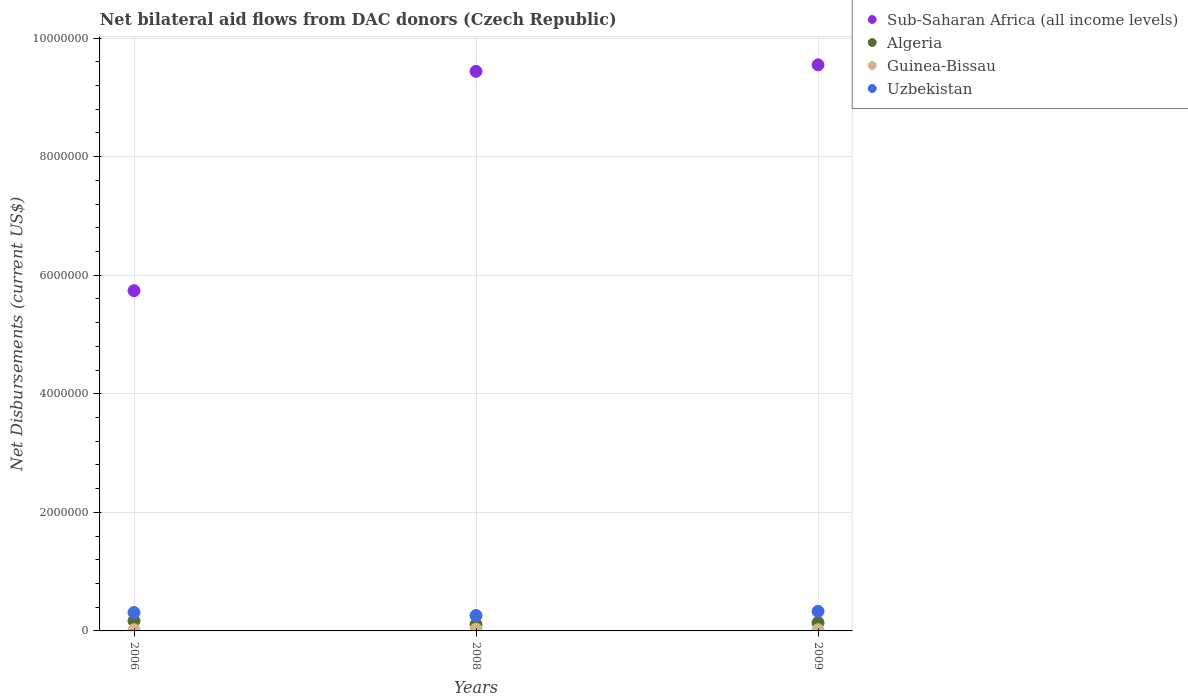How many different coloured dotlines are there?
Make the answer very short. 4. Is the number of dotlines equal to the number of legend labels?
Provide a short and direct response. Yes. What is the net bilateral aid flows in Algeria in 2008?
Your answer should be very brief. 1.10e+05. In which year was the net bilateral aid flows in Guinea-Bissau maximum?
Your answer should be compact. 2008. What is the total net bilateral aid flows in Guinea-Bissau in the graph?
Provide a short and direct response. 7.00e+04. What is the difference between the net bilateral aid flows in Uzbekistan in 2006 and that in 2008?
Offer a terse response. 5.00e+04. What is the difference between the net bilateral aid flows in Uzbekistan in 2006 and the net bilateral aid flows in Sub-Saharan Africa (all income levels) in 2009?
Your answer should be very brief. -9.24e+06. What is the average net bilateral aid flows in Guinea-Bissau per year?
Offer a very short reply. 2.33e+04. In how many years, is the net bilateral aid flows in Algeria greater than 9200000 US$?
Provide a short and direct response. 0. What is the ratio of the net bilateral aid flows in Uzbekistan in 2006 to that in 2008?
Ensure brevity in your answer.  1.19. What is the difference between the highest and the second highest net bilateral aid flows in Algeria?
Offer a terse response. 3.00e+04. What is the difference between the highest and the lowest net bilateral aid flows in Algeria?
Offer a terse response. 6.00e+04. Is the sum of the net bilateral aid flows in Guinea-Bissau in 2006 and 2008 greater than the maximum net bilateral aid flows in Algeria across all years?
Make the answer very short. No. Is it the case that in every year, the sum of the net bilateral aid flows in Sub-Saharan Africa (all income levels) and net bilateral aid flows in Guinea-Bissau  is greater than the sum of net bilateral aid flows in Algeria and net bilateral aid flows in Uzbekistan?
Ensure brevity in your answer.  Yes. Is the net bilateral aid flows in Uzbekistan strictly less than the net bilateral aid flows in Algeria over the years?
Offer a terse response. No. How many dotlines are there?
Your response must be concise. 4. How many years are there in the graph?
Keep it short and to the point. 3. What is the difference between two consecutive major ticks on the Y-axis?
Give a very brief answer. 2.00e+06. Are the values on the major ticks of Y-axis written in scientific E-notation?
Keep it short and to the point. No. Does the graph contain any zero values?
Give a very brief answer. No. Where does the legend appear in the graph?
Provide a succinct answer. Top right. How many legend labels are there?
Give a very brief answer. 4. How are the legend labels stacked?
Ensure brevity in your answer.  Vertical. What is the title of the graph?
Provide a short and direct response. Net bilateral aid flows from DAC donors (Czech Republic). What is the label or title of the X-axis?
Offer a very short reply. Years. What is the label or title of the Y-axis?
Offer a very short reply. Net Disbursements (current US$). What is the Net Disbursements (current US$) of Sub-Saharan Africa (all income levels) in 2006?
Provide a short and direct response. 5.74e+06. What is the Net Disbursements (current US$) of Algeria in 2006?
Keep it short and to the point. 1.70e+05. What is the Net Disbursements (current US$) in Sub-Saharan Africa (all income levels) in 2008?
Keep it short and to the point. 9.44e+06. What is the Net Disbursements (current US$) in Algeria in 2008?
Give a very brief answer. 1.10e+05. What is the Net Disbursements (current US$) of Guinea-Bissau in 2008?
Your response must be concise. 3.00e+04. What is the Net Disbursements (current US$) in Uzbekistan in 2008?
Your answer should be compact. 2.60e+05. What is the Net Disbursements (current US$) in Sub-Saharan Africa (all income levels) in 2009?
Your answer should be very brief. 9.55e+06. What is the Net Disbursements (current US$) in Uzbekistan in 2009?
Give a very brief answer. 3.30e+05. Across all years, what is the maximum Net Disbursements (current US$) of Sub-Saharan Africa (all income levels)?
Keep it short and to the point. 9.55e+06. Across all years, what is the maximum Net Disbursements (current US$) in Algeria?
Your response must be concise. 1.70e+05. Across all years, what is the minimum Net Disbursements (current US$) in Sub-Saharan Africa (all income levels)?
Your response must be concise. 5.74e+06. Across all years, what is the minimum Net Disbursements (current US$) of Algeria?
Offer a very short reply. 1.10e+05. Across all years, what is the minimum Net Disbursements (current US$) in Guinea-Bissau?
Your answer should be very brief. 2.00e+04. Across all years, what is the minimum Net Disbursements (current US$) of Uzbekistan?
Make the answer very short. 2.60e+05. What is the total Net Disbursements (current US$) of Sub-Saharan Africa (all income levels) in the graph?
Keep it short and to the point. 2.47e+07. What is the total Net Disbursements (current US$) of Guinea-Bissau in the graph?
Offer a terse response. 7.00e+04. What is the total Net Disbursements (current US$) in Uzbekistan in the graph?
Keep it short and to the point. 9.00e+05. What is the difference between the Net Disbursements (current US$) in Sub-Saharan Africa (all income levels) in 2006 and that in 2008?
Provide a succinct answer. -3.70e+06. What is the difference between the Net Disbursements (current US$) in Algeria in 2006 and that in 2008?
Keep it short and to the point. 6.00e+04. What is the difference between the Net Disbursements (current US$) of Uzbekistan in 2006 and that in 2008?
Make the answer very short. 5.00e+04. What is the difference between the Net Disbursements (current US$) in Sub-Saharan Africa (all income levels) in 2006 and that in 2009?
Keep it short and to the point. -3.81e+06. What is the difference between the Net Disbursements (current US$) of Algeria in 2006 and that in 2009?
Provide a succinct answer. 3.00e+04. What is the difference between the Net Disbursements (current US$) of Sub-Saharan Africa (all income levels) in 2008 and that in 2009?
Your response must be concise. -1.10e+05. What is the difference between the Net Disbursements (current US$) in Sub-Saharan Africa (all income levels) in 2006 and the Net Disbursements (current US$) in Algeria in 2008?
Give a very brief answer. 5.63e+06. What is the difference between the Net Disbursements (current US$) of Sub-Saharan Africa (all income levels) in 2006 and the Net Disbursements (current US$) of Guinea-Bissau in 2008?
Provide a succinct answer. 5.71e+06. What is the difference between the Net Disbursements (current US$) in Sub-Saharan Africa (all income levels) in 2006 and the Net Disbursements (current US$) in Uzbekistan in 2008?
Make the answer very short. 5.48e+06. What is the difference between the Net Disbursements (current US$) of Algeria in 2006 and the Net Disbursements (current US$) of Guinea-Bissau in 2008?
Offer a terse response. 1.40e+05. What is the difference between the Net Disbursements (current US$) of Algeria in 2006 and the Net Disbursements (current US$) of Uzbekistan in 2008?
Give a very brief answer. -9.00e+04. What is the difference between the Net Disbursements (current US$) of Sub-Saharan Africa (all income levels) in 2006 and the Net Disbursements (current US$) of Algeria in 2009?
Keep it short and to the point. 5.60e+06. What is the difference between the Net Disbursements (current US$) of Sub-Saharan Africa (all income levels) in 2006 and the Net Disbursements (current US$) of Guinea-Bissau in 2009?
Offer a very short reply. 5.72e+06. What is the difference between the Net Disbursements (current US$) of Sub-Saharan Africa (all income levels) in 2006 and the Net Disbursements (current US$) of Uzbekistan in 2009?
Your answer should be compact. 5.41e+06. What is the difference between the Net Disbursements (current US$) of Algeria in 2006 and the Net Disbursements (current US$) of Guinea-Bissau in 2009?
Offer a terse response. 1.50e+05. What is the difference between the Net Disbursements (current US$) of Algeria in 2006 and the Net Disbursements (current US$) of Uzbekistan in 2009?
Your answer should be compact. -1.60e+05. What is the difference between the Net Disbursements (current US$) of Guinea-Bissau in 2006 and the Net Disbursements (current US$) of Uzbekistan in 2009?
Give a very brief answer. -3.10e+05. What is the difference between the Net Disbursements (current US$) of Sub-Saharan Africa (all income levels) in 2008 and the Net Disbursements (current US$) of Algeria in 2009?
Offer a terse response. 9.30e+06. What is the difference between the Net Disbursements (current US$) of Sub-Saharan Africa (all income levels) in 2008 and the Net Disbursements (current US$) of Guinea-Bissau in 2009?
Your response must be concise. 9.42e+06. What is the difference between the Net Disbursements (current US$) in Sub-Saharan Africa (all income levels) in 2008 and the Net Disbursements (current US$) in Uzbekistan in 2009?
Provide a succinct answer. 9.11e+06. What is the difference between the Net Disbursements (current US$) in Algeria in 2008 and the Net Disbursements (current US$) in Guinea-Bissau in 2009?
Offer a very short reply. 9.00e+04. What is the difference between the Net Disbursements (current US$) in Guinea-Bissau in 2008 and the Net Disbursements (current US$) in Uzbekistan in 2009?
Offer a terse response. -3.00e+05. What is the average Net Disbursements (current US$) of Sub-Saharan Africa (all income levels) per year?
Your response must be concise. 8.24e+06. What is the average Net Disbursements (current US$) of Guinea-Bissau per year?
Provide a short and direct response. 2.33e+04. In the year 2006, what is the difference between the Net Disbursements (current US$) of Sub-Saharan Africa (all income levels) and Net Disbursements (current US$) of Algeria?
Offer a very short reply. 5.57e+06. In the year 2006, what is the difference between the Net Disbursements (current US$) in Sub-Saharan Africa (all income levels) and Net Disbursements (current US$) in Guinea-Bissau?
Your answer should be very brief. 5.72e+06. In the year 2006, what is the difference between the Net Disbursements (current US$) of Sub-Saharan Africa (all income levels) and Net Disbursements (current US$) of Uzbekistan?
Give a very brief answer. 5.43e+06. In the year 2008, what is the difference between the Net Disbursements (current US$) in Sub-Saharan Africa (all income levels) and Net Disbursements (current US$) in Algeria?
Provide a short and direct response. 9.33e+06. In the year 2008, what is the difference between the Net Disbursements (current US$) in Sub-Saharan Africa (all income levels) and Net Disbursements (current US$) in Guinea-Bissau?
Give a very brief answer. 9.41e+06. In the year 2008, what is the difference between the Net Disbursements (current US$) in Sub-Saharan Africa (all income levels) and Net Disbursements (current US$) in Uzbekistan?
Make the answer very short. 9.18e+06. In the year 2008, what is the difference between the Net Disbursements (current US$) of Algeria and Net Disbursements (current US$) of Uzbekistan?
Offer a terse response. -1.50e+05. In the year 2008, what is the difference between the Net Disbursements (current US$) of Guinea-Bissau and Net Disbursements (current US$) of Uzbekistan?
Your answer should be compact. -2.30e+05. In the year 2009, what is the difference between the Net Disbursements (current US$) in Sub-Saharan Africa (all income levels) and Net Disbursements (current US$) in Algeria?
Offer a terse response. 9.41e+06. In the year 2009, what is the difference between the Net Disbursements (current US$) of Sub-Saharan Africa (all income levels) and Net Disbursements (current US$) of Guinea-Bissau?
Provide a short and direct response. 9.53e+06. In the year 2009, what is the difference between the Net Disbursements (current US$) of Sub-Saharan Africa (all income levels) and Net Disbursements (current US$) of Uzbekistan?
Your answer should be very brief. 9.22e+06. In the year 2009, what is the difference between the Net Disbursements (current US$) of Algeria and Net Disbursements (current US$) of Uzbekistan?
Offer a terse response. -1.90e+05. In the year 2009, what is the difference between the Net Disbursements (current US$) in Guinea-Bissau and Net Disbursements (current US$) in Uzbekistan?
Offer a terse response. -3.10e+05. What is the ratio of the Net Disbursements (current US$) in Sub-Saharan Africa (all income levels) in 2006 to that in 2008?
Provide a succinct answer. 0.61. What is the ratio of the Net Disbursements (current US$) in Algeria in 2006 to that in 2008?
Your answer should be compact. 1.55. What is the ratio of the Net Disbursements (current US$) of Guinea-Bissau in 2006 to that in 2008?
Give a very brief answer. 0.67. What is the ratio of the Net Disbursements (current US$) of Uzbekistan in 2006 to that in 2008?
Offer a terse response. 1.19. What is the ratio of the Net Disbursements (current US$) of Sub-Saharan Africa (all income levels) in 2006 to that in 2009?
Your answer should be very brief. 0.6. What is the ratio of the Net Disbursements (current US$) of Algeria in 2006 to that in 2009?
Your answer should be compact. 1.21. What is the ratio of the Net Disbursements (current US$) in Guinea-Bissau in 2006 to that in 2009?
Make the answer very short. 1. What is the ratio of the Net Disbursements (current US$) of Uzbekistan in 2006 to that in 2009?
Make the answer very short. 0.94. What is the ratio of the Net Disbursements (current US$) in Algeria in 2008 to that in 2009?
Keep it short and to the point. 0.79. What is the ratio of the Net Disbursements (current US$) in Guinea-Bissau in 2008 to that in 2009?
Ensure brevity in your answer.  1.5. What is the ratio of the Net Disbursements (current US$) of Uzbekistan in 2008 to that in 2009?
Your answer should be very brief. 0.79. What is the difference between the highest and the second highest Net Disbursements (current US$) of Algeria?
Your answer should be compact. 3.00e+04. What is the difference between the highest and the second highest Net Disbursements (current US$) of Uzbekistan?
Keep it short and to the point. 2.00e+04. What is the difference between the highest and the lowest Net Disbursements (current US$) of Sub-Saharan Africa (all income levels)?
Offer a very short reply. 3.81e+06. What is the difference between the highest and the lowest Net Disbursements (current US$) in Guinea-Bissau?
Your answer should be very brief. 10000. What is the difference between the highest and the lowest Net Disbursements (current US$) in Uzbekistan?
Provide a short and direct response. 7.00e+04. 